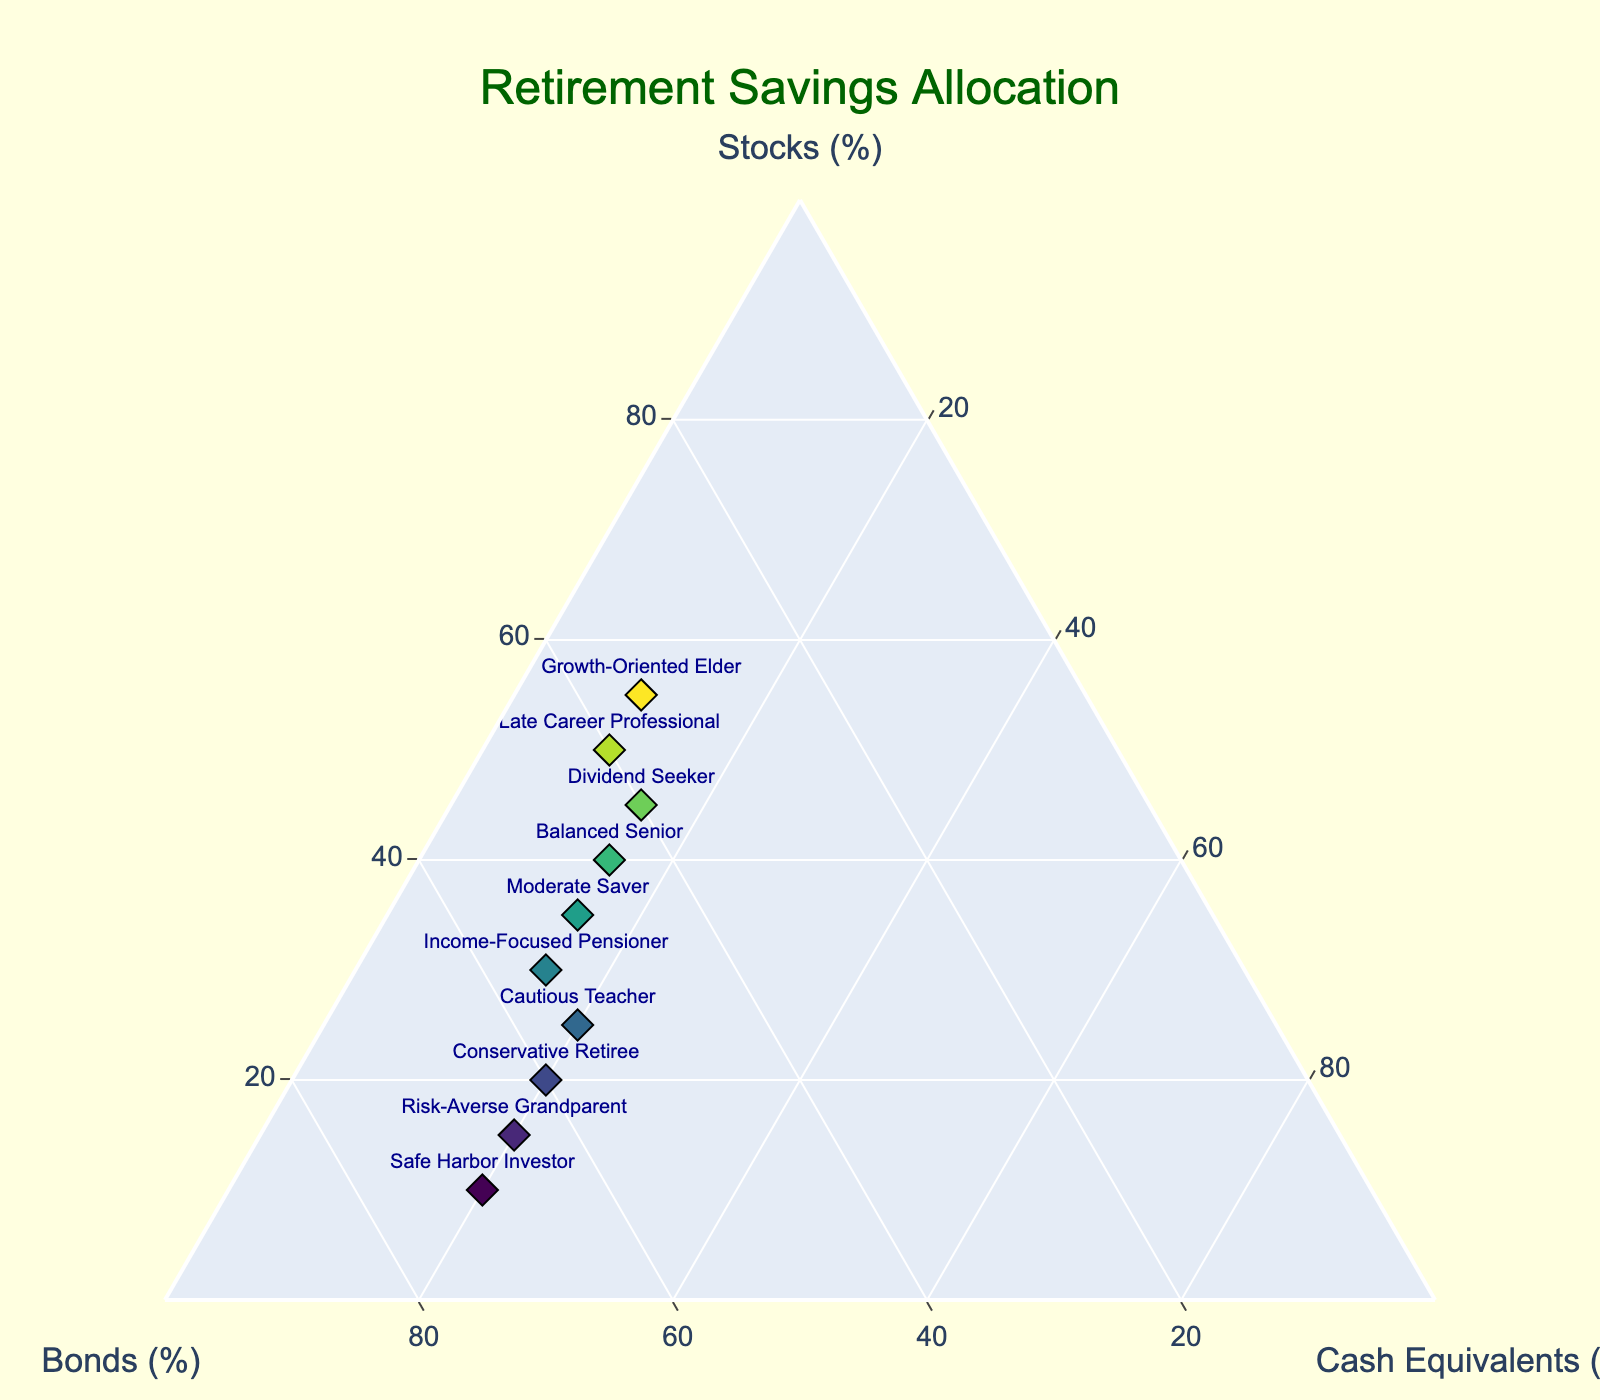How many types of investors are plotted in the figure? The figure includes points for each type of investor listed. Count the labels on the plot.
Answer: 10 Which investor has the highest percentage of bonds? Look at the points along the Bonds axis and identify the highest value.
Answer: Safe Harbor Investor What is the difference in stock allocation between the Growth-Oriented Elder and the Cautious Teacher? The Growth-Oriented Elder has 55% in stocks, while the Cautious Teacher has 25%. The difference is 55% - 25%.
Answer: 30% Is there any investor who has an equal allocation of cash equivalents and the sum of their stocks and bonds? Calculate the total stocks and bonds for each investor and compare it to their cash equivalents.
Answer: No What's the average allocation for stocks among all investors? Sum up all the stock percentages and divide by the number of investors.
Answer: 32% Which investor has a more balanced allocation between stocks, bonds, and cash equivalents? Look for the point closest to the center of the ternary plot, where all allocations are nearly equal.
Answer: Balanced Senior Compare the stock allocation between the Balanced Senior and the Income-Focused Pensioner. Who has more stocks, and by how much? The Balanced Senior has 40% in stocks while the Income-Focused Pensioner has 30%. The difference is 40% - 30%.
Answer: Balanced Senior by 10% What's the median value for bonds allocation among the investors? Arrange the bond percentages in ascending order and find the middle value.
Answer: 55% Who are the two investors with the highest bond allocation, and how do their cash equivalents compare? Identify the top two investors with the highest bond values, then compare their cash equivalents values.
Answer: Safe Harbor Investor and Risk-Averse Grandparent; both have 20% in cash equivalents 